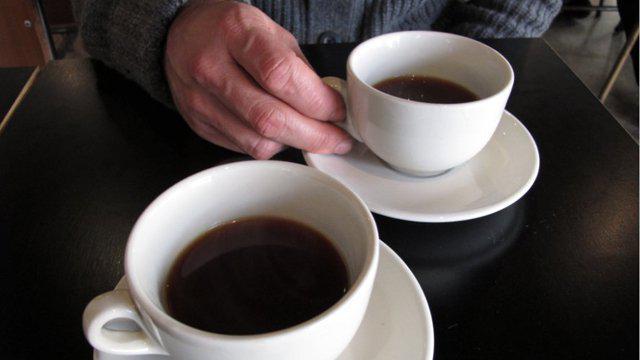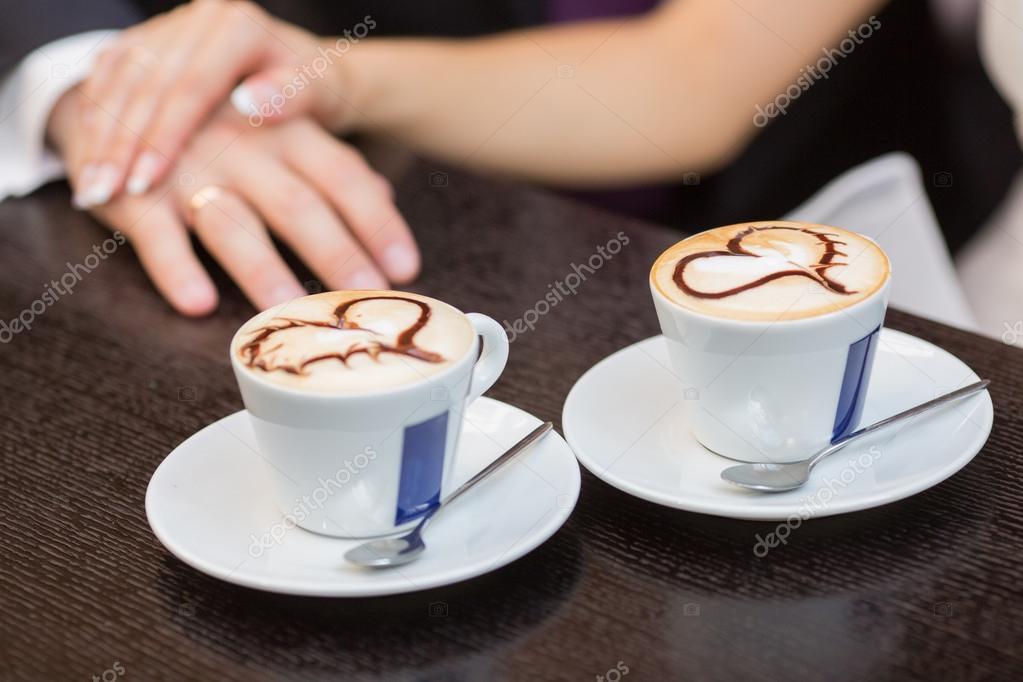The first image is the image on the left, the second image is the image on the right. Evaluate the accuracy of this statement regarding the images: "Only one image includes human hands with mugs of hot beverages.". Is it true? Answer yes or no. No. 